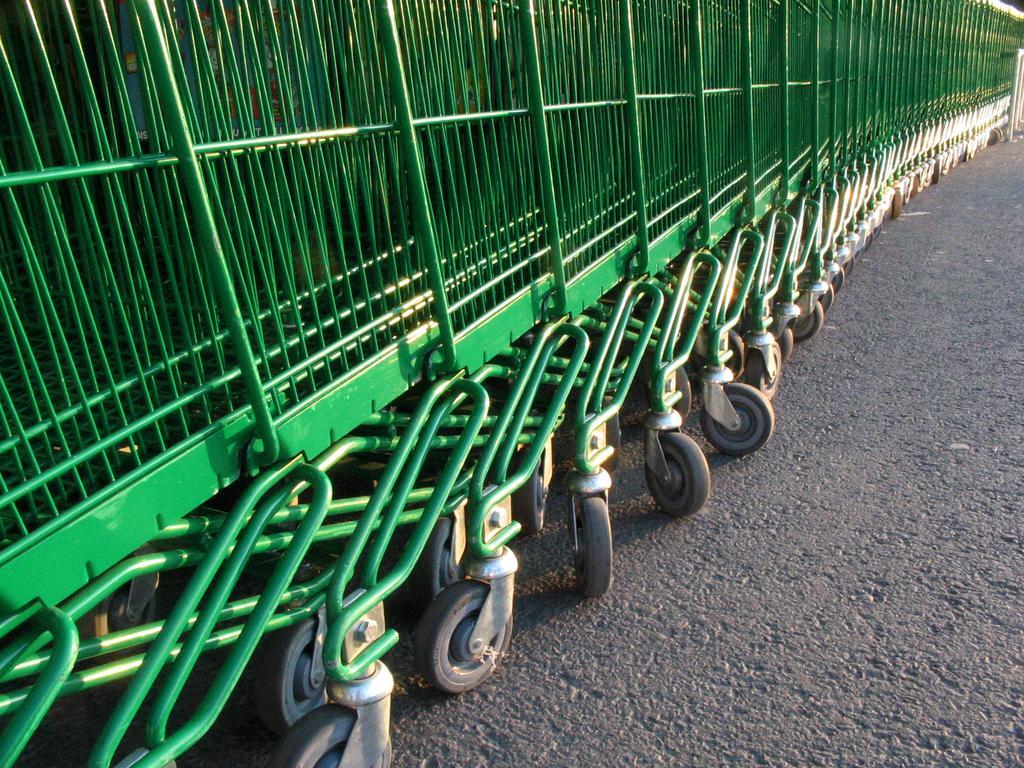How would you summarize this image in a sentence or two? There are plenty of trolleys kept in a row. They are of green color. 